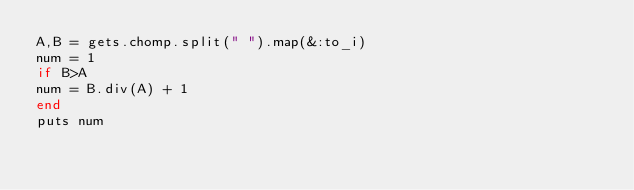Convert code to text. <code><loc_0><loc_0><loc_500><loc_500><_Ruby_>A,B = gets.chomp.split(" ").map(&:to_i)
num = 1
if B>A
num = B.div(A) + 1
end
puts num</code> 